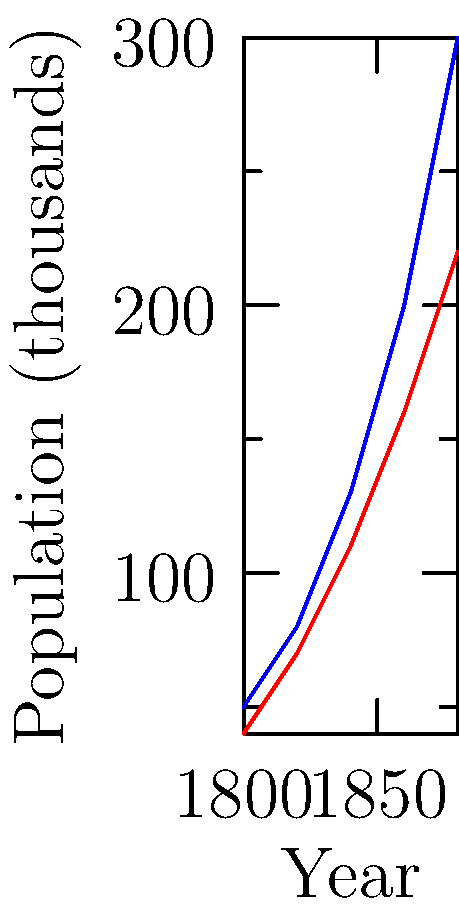As a descendant of an industrialist, you are analyzing the population growth of two industrial cities during the Industrial Revolution. The graph shows the population growth of City A and City B from 1800 to 1880. In which year did the population difference between the two cities exceed 50,000 people for the first time? To solve this question, we need to follow these steps:

1. Calculate the population difference between City A and City B for each given year.
2. Identify the first year when this difference exceeds 50,000 people.

Let's calculate the differences:

1800: $50,000 - 40,000 = 10,000$
1820: $80,000 - 70,000 = 10,000$
1840: $130,000 - 110,000 = 20,000$
1860: $200,000 - 160,000 = 40,000$
1880: $300,000 - 220,000 = 80,000$

We can see that the difference first exceeds 50,000 people in 1880. This aligns with the rapid population growth often seen in industrial cities during the later stages of the Industrial Revolution, as more people moved from rural areas to urban centers for work opportunities.
Answer: 1880 